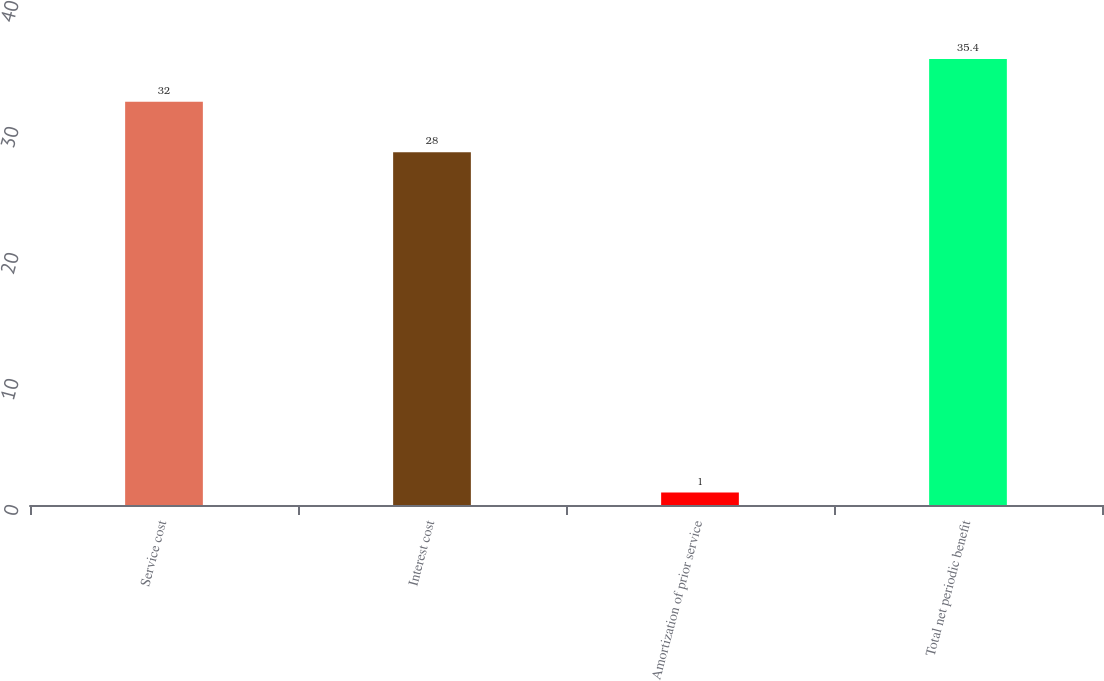<chart> <loc_0><loc_0><loc_500><loc_500><bar_chart><fcel>Service cost<fcel>Interest cost<fcel>Amortization of prior service<fcel>Total net periodic benefit<nl><fcel>32<fcel>28<fcel>1<fcel>35.4<nl></chart> 